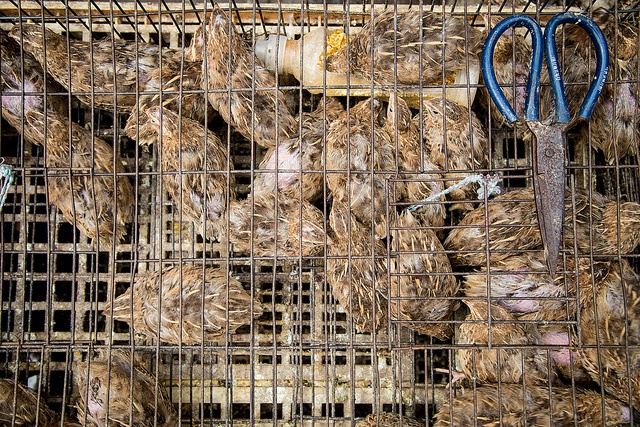Describe the objects in this image and their specific colors. I can see bird in gray, black, and maroon tones, scissors in gray, black, navy, and darkgray tones, bird in gray, tan, olive, and black tones, bird in gray, tan, and darkgray tones, and bird in gray, tan, and darkgray tones in this image. 